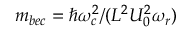Convert formula to latex. <formula><loc_0><loc_0><loc_500><loc_500>m _ { b e c } = \hslash \omega _ { c } ^ { 2 } / ( L ^ { 2 } U _ { 0 } ^ { 2 } \omega _ { r } )</formula> 